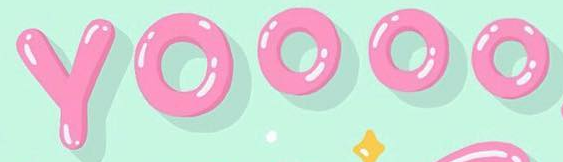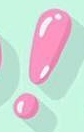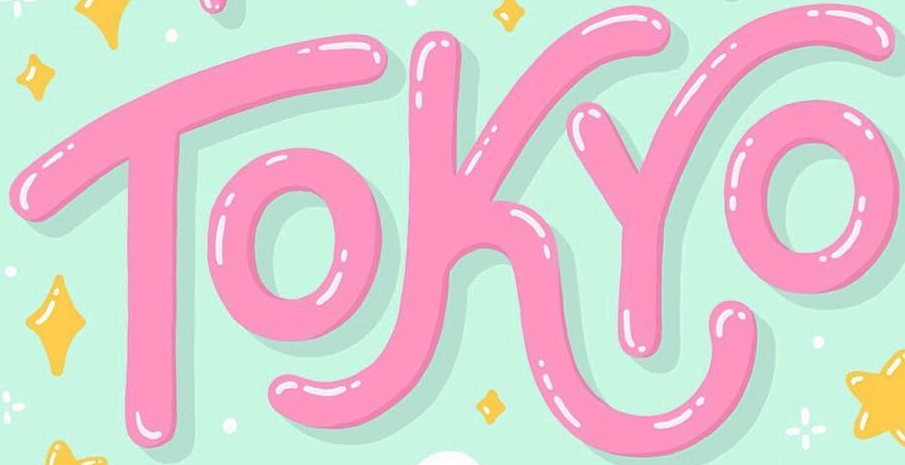Transcribe the words shown in these images in order, separated by a semicolon. YOOOO; !; TOKYO 